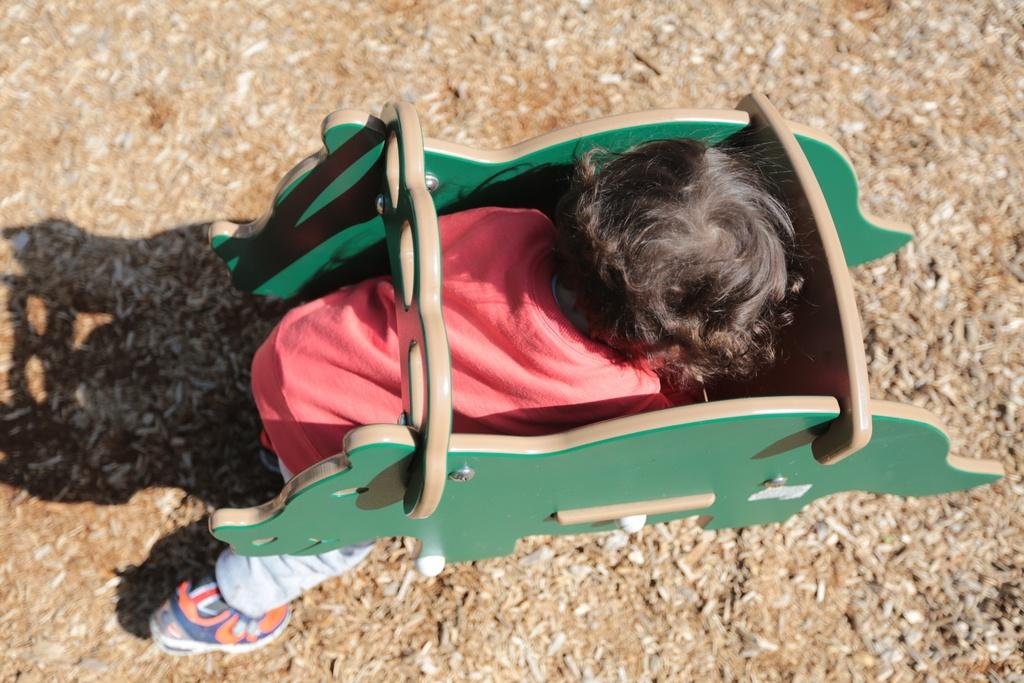What is the main subject of the image? There is a child in the image. What is the child doing in the image? The child is trying to sit on a wooden toy. Where is the wooden toy located in the image? The wooden toy is present on the ground. What theory does the child have about the cemetery in the image? There is no cemetery present in the image, so the child cannot have a theory about it. 